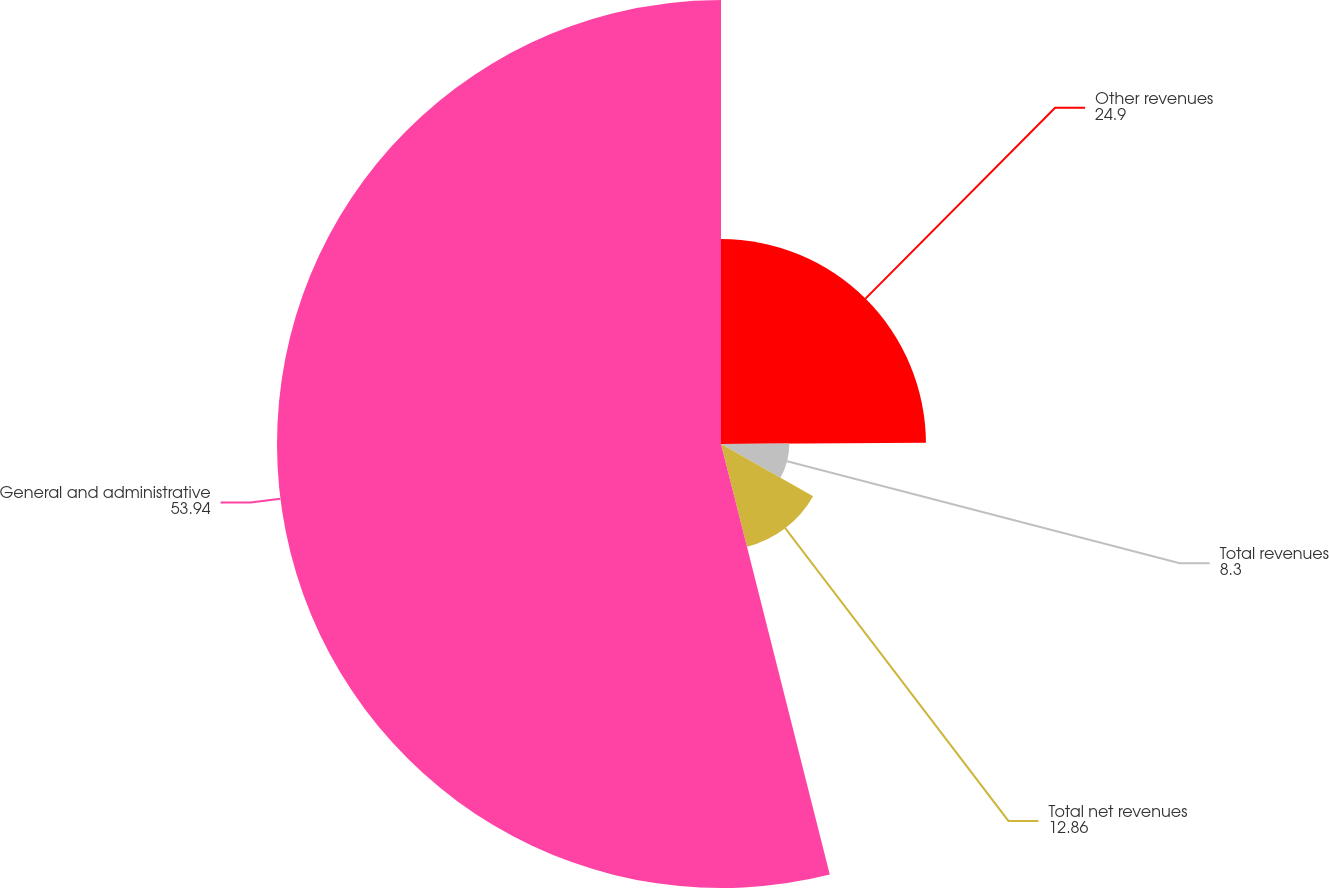<chart> <loc_0><loc_0><loc_500><loc_500><pie_chart><fcel>Other revenues<fcel>Total revenues<fcel>Total net revenues<fcel>General and administrative<nl><fcel>24.9%<fcel>8.3%<fcel>12.86%<fcel>53.94%<nl></chart> 